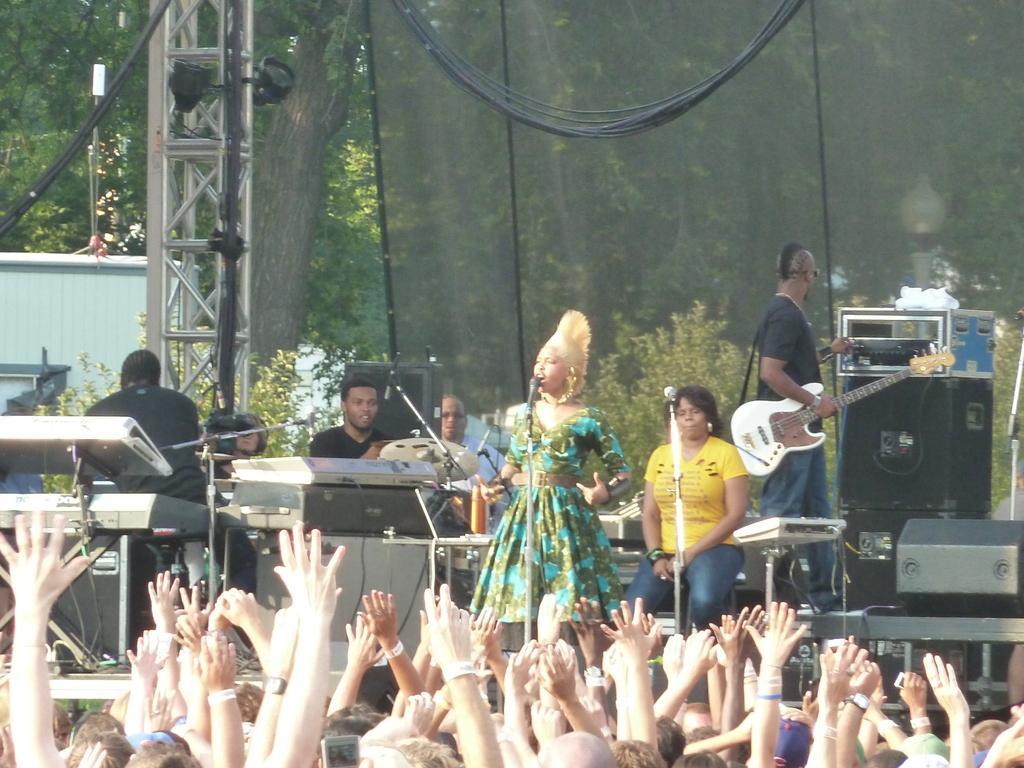Could you give a brief overview of what you see in this image? This images clicked in a musical concert where there are trees on the top ,there people on the stage who are playing musical instruments. The one who is in the middle is singing. People in the bottom are raising their hands to cheer up. There are trees on the left side and behind this people there is an net. Wires are on the top. There are lights on the left side. 